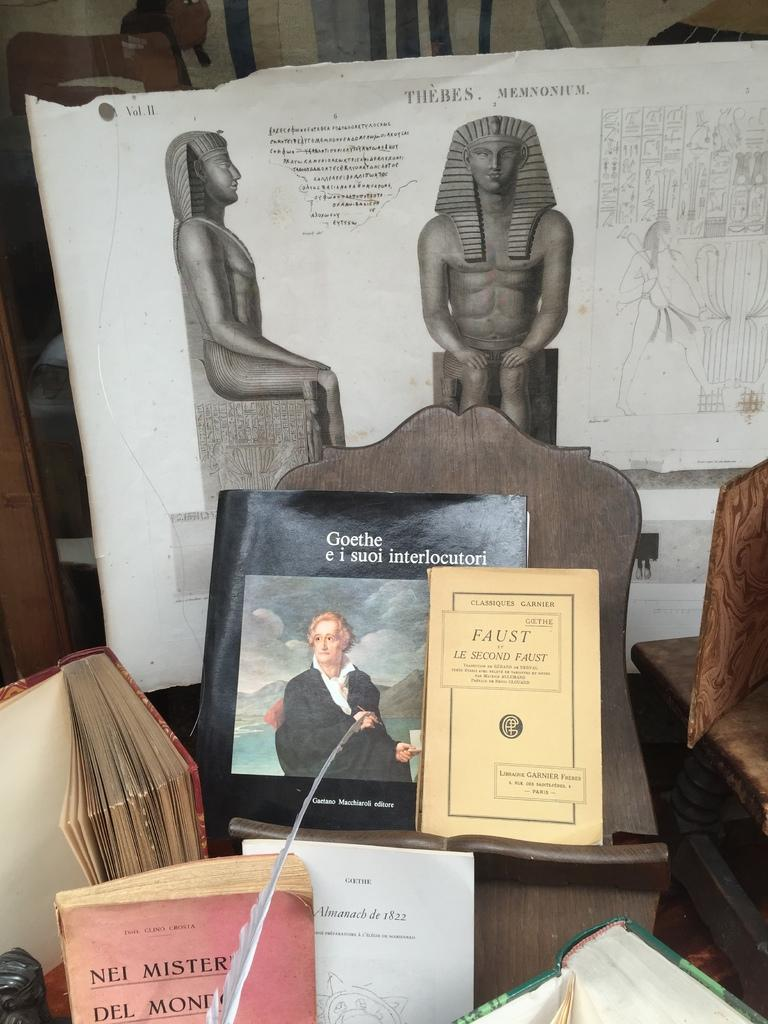<image>
Relay a brief, clear account of the picture shown. Display showing a statue and also a book that says "Nei Mister Del Mond" on it. 